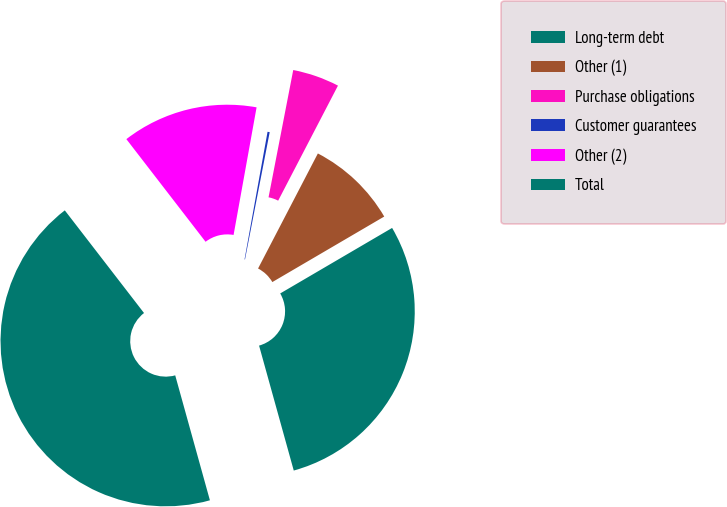<chart> <loc_0><loc_0><loc_500><loc_500><pie_chart><fcel>Long-term debt<fcel>Other (1)<fcel>Purchase obligations<fcel>Customer guarantees<fcel>Other (2)<fcel>Total<nl><fcel>29.12%<fcel>8.94%<fcel>4.58%<fcel>0.21%<fcel>13.3%<fcel>43.85%<nl></chart> 